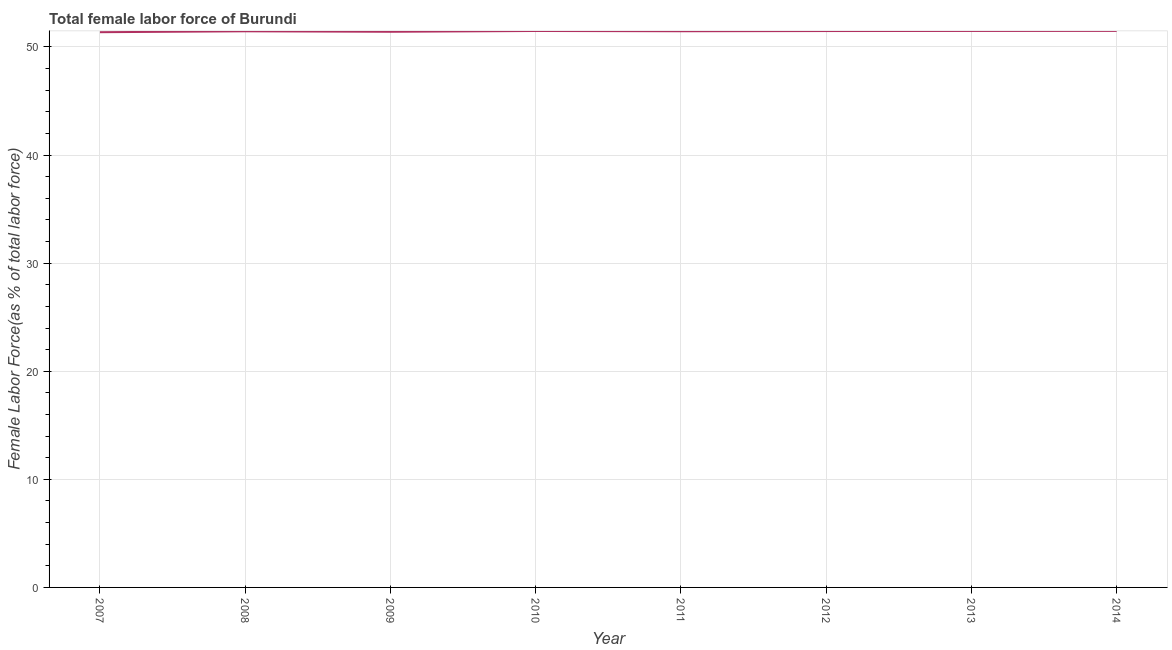What is the total female labor force in 2007?
Your response must be concise. 51.37. Across all years, what is the maximum total female labor force?
Keep it short and to the point. 51.49. Across all years, what is the minimum total female labor force?
Make the answer very short. 51.37. In which year was the total female labor force maximum?
Make the answer very short. 2014. What is the sum of the total female labor force?
Keep it short and to the point. 411.6. What is the difference between the total female labor force in 2007 and 2012?
Ensure brevity in your answer.  -0.11. What is the average total female labor force per year?
Your answer should be very brief. 51.45. What is the median total female labor force?
Your answer should be compact. 51.46. What is the ratio of the total female labor force in 2010 to that in 2011?
Offer a very short reply. 1. What is the difference between the highest and the second highest total female labor force?
Your answer should be compact. 0.01. What is the difference between the highest and the lowest total female labor force?
Your answer should be compact. 0.12. In how many years, is the total female labor force greater than the average total female labor force taken over all years?
Keep it short and to the point. 6. Does the total female labor force monotonically increase over the years?
Provide a short and direct response. No. How many years are there in the graph?
Offer a terse response. 8. Does the graph contain any zero values?
Offer a very short reply. No. What is the title of the graph?
Make the answer very short. Total female labor force of Burundi. What is the label or title of the Y-axis?
Offer a very short reply. Female Labor Force(as % of total labor force). What is the Female Labor Force(as % of total labor force) in 2007?
Keep it short and to the point. 51.37. What is the Female Labor Force(as % of total labor force) of 2008?
Your response must be concise. 51.45. What is the Female Labor Force(as % of total labor force) of 2009?
Keep it short and to the point. 51.41. What is the Female Labor Force(as % of total labor force) of 2010?
Offer a very short reply. 51.48. What is the Female Labor Force(as % of total labor force) of 2011?
Ensure brevity in your answer.  51.45. What is the Female Labor Force(as % of total labor force) of 2012?
Make the answer very short. 51.47. What is the Female Labor Force(as % of total labor force) of 2013?
Your response must be concise. 51.48. What is the Female Labor Force(as % of total labor force) of 2014?
Provide a short and direct response. 51.49. What is the difference between the Female Labor Force(as % of total labor force) in 2007 and 2008?
Your answer should be very brief. -0.08. What is the difference between the Female Labor Force(as % of total labor force) in 2007 and 2009?
Your answer should be compact. -0.04. What is the difference between the Female Labor Force(as % of total labor force) in 2007 and 2010?
Your answer should be very brief. -0.11. What is the difference between the Female Labor Force(as % of total labor force) in 2007 and 2011?
Keep it short and to the point. -0.09. What is the difference between the Female Labor Force(as % of total labor force) in 2007 and 2012?
Keep it short and to the point. -0.11. What is the difference between the Female Labor Force(as % of total labor force) in 2007 and 2013?
Your response must be concise. -0.12. What is the difference between the Female Labor Force(as % of total labor force) in 2007 and 2014?
Offer a very short reply. -0.12. What is the difference between the Female Labor Force(as % of total labor force) in 2008 and 2009?
Your answer should be compact. 0.04. What is the difference between the Female Labor Force(as % of total labor force) in 2008 and 2010?
Offer a terse response. -0.03. What is the difference between the Female Labor Force(as % of total labor force) in 2008 and 2011?
Your answer should be very brief. -0. What is the difference between the Female Labor Force(as % of total labor force) in 2008 and 2012?
Your answer should be very brief. -0.02. What is the difference between the Female Labor Force(as % of total labor force) in 2008 and 2013?
Ensure brevity in your answer.  -0.03. What is the difference between the Female Labor Force(as % of total labor force) in 2008 and 2014?
Offer a very short reply. -0.04. What is the difference between the Female Labor Force(as % of total labor force) in 2009 and 2010?
Provide a short and direct response. -0.07. What is the difference between the Female Labor Force(as % of total labor force) in 2009 and 2011?
Keep it short and to the point. -0.05. What is the difference between the Female Labor Force(as % of total labor force) in 2009 and 2012?
Keep it short and to the point. -0.07. What is the difference between the Female Labor Force(as % of total labor force) in 2009 and 2013?
Your answer should be very brief. -0.08. What is the difference between the Female Labor Force(as % of total labor force) in 2009 and 2014?
Your answer should be very brief. -0.08. What is the difference between the Female Labor Force(as % of total labor force) in 2010 and 2011?
Ensure brevity in your answer.  0.03. What is the difference between the Female Labor Force(as % of total labor force) in 2010 and 2012?
Make the answer very short. 0.01. What is the difference between the Female Labor Force(as % of total labor force) in 2010 and 2013?
Give a very brief answer. -0. What is the difference between the Female Labor Force(as % of total labor force) in 2010 and 2014?
Provide a short and direct response. -0.01. What is the difference between the Female Labor Force(as % of total labor force) in 2011 and 2012?
Give a very brief answer. -0.02. What is the difference between the Female Labor Force(as % of total labor force) in 2011 and 2013?
Make the answer very short. -0.03. What is the difference between the Female Labor Force(as % of total labor force) in 2011 and 2014?
Keep it short and to the point. -0.03. What is the difference between the Female Labor Force(as % of total labor force) in 2012 and 2013?
Make the answer very short. -0.01. What is the difference between the Female Labor Force(as % of total labor force) in 2012 and 2014?
Ensure brevity in your answer.  -0.01. What is the difference between the Female Labor Force(as % of total labor force) in 2013 and 2014?
Offer a very short reply. -0.01. What is the ratio of the Female Labor Force(as % of total labor force) in 2007 to that in 2010?
Give a very brief answer. 1. What is the ratio of the Female Labor Force(as % of total labor force) in 2007 to that in 2011?
Your answer should be compact. 1. What is the ratio of the Female Labor Force(as % of total labor force) in 2007 to that in 2013?
Ensure brevity in your answer.  1. What is the ratio of the Female Labor Force(as % of total labor force) in 2008 to that in 2009?
Keep it short and to the point. 1. What is the ratio of the Female Labor Force(as % of total labor force) in 2008 to that in 2010?
Provide a succinct answer. 1. What is the ratio of the Female Labor Force(as % of total labor force) in 2008 to that in 2013?
Your answer should be very brief. 1. What is the ratio of the Female Labor Force(as % of total labor force) in 2009 to that in 2010?
Offer a very short reply. 1. What is the ratio of the Female Labor Force(as % of total labor force) in 2009 to that in 2011?
Offer a terse response. 1. What is the ratio of the Female Labor Force(as % of total labor force) in 2009 to that in 2012?
Your answer should be compact. 1. What is the ratio of the Female Labor Force(as % of total labor force) in 2010 to that in 2014?
Keep it short and to the point. 1. What is the ratio of the Female Labor Force(as % of total labor force) in 2011 to that in 2013?
Your answer should be very brief. 1. What is the ratio of the Female Labor Force(as % of total labor force) in 2012 to that in 2013?
Keep it short and to the point. 1. What is the ratio of the Female Labor Force(as % of total labor force) in 2013 to that in 2014?
Give a very brief answer. 1. 